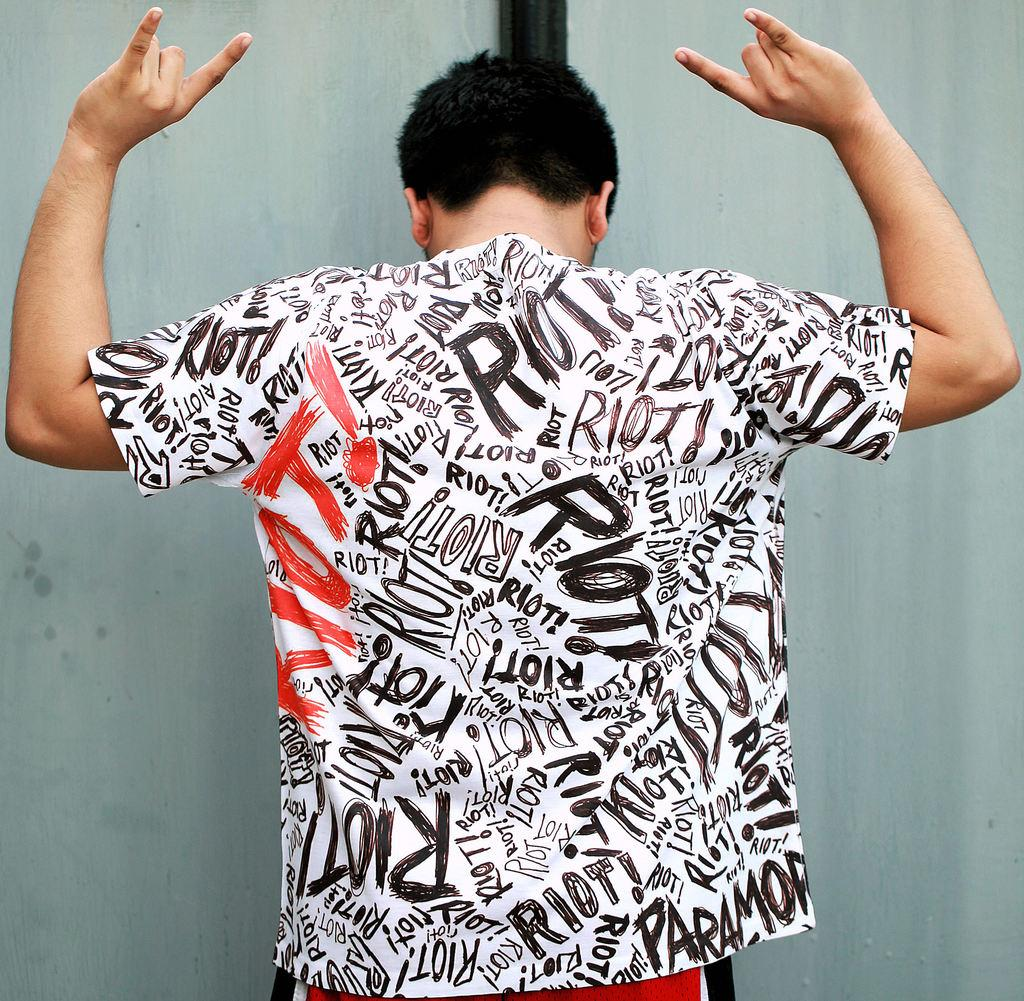Provide a one-sentence caption for the provided image. A black, white, and red shirt that has the word riot all over it. 